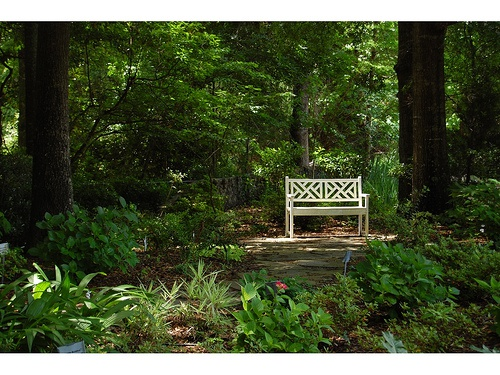Describe the objects in this image and their specific colors. I can see a bench in white, beige, black, and olive tones in this image. 